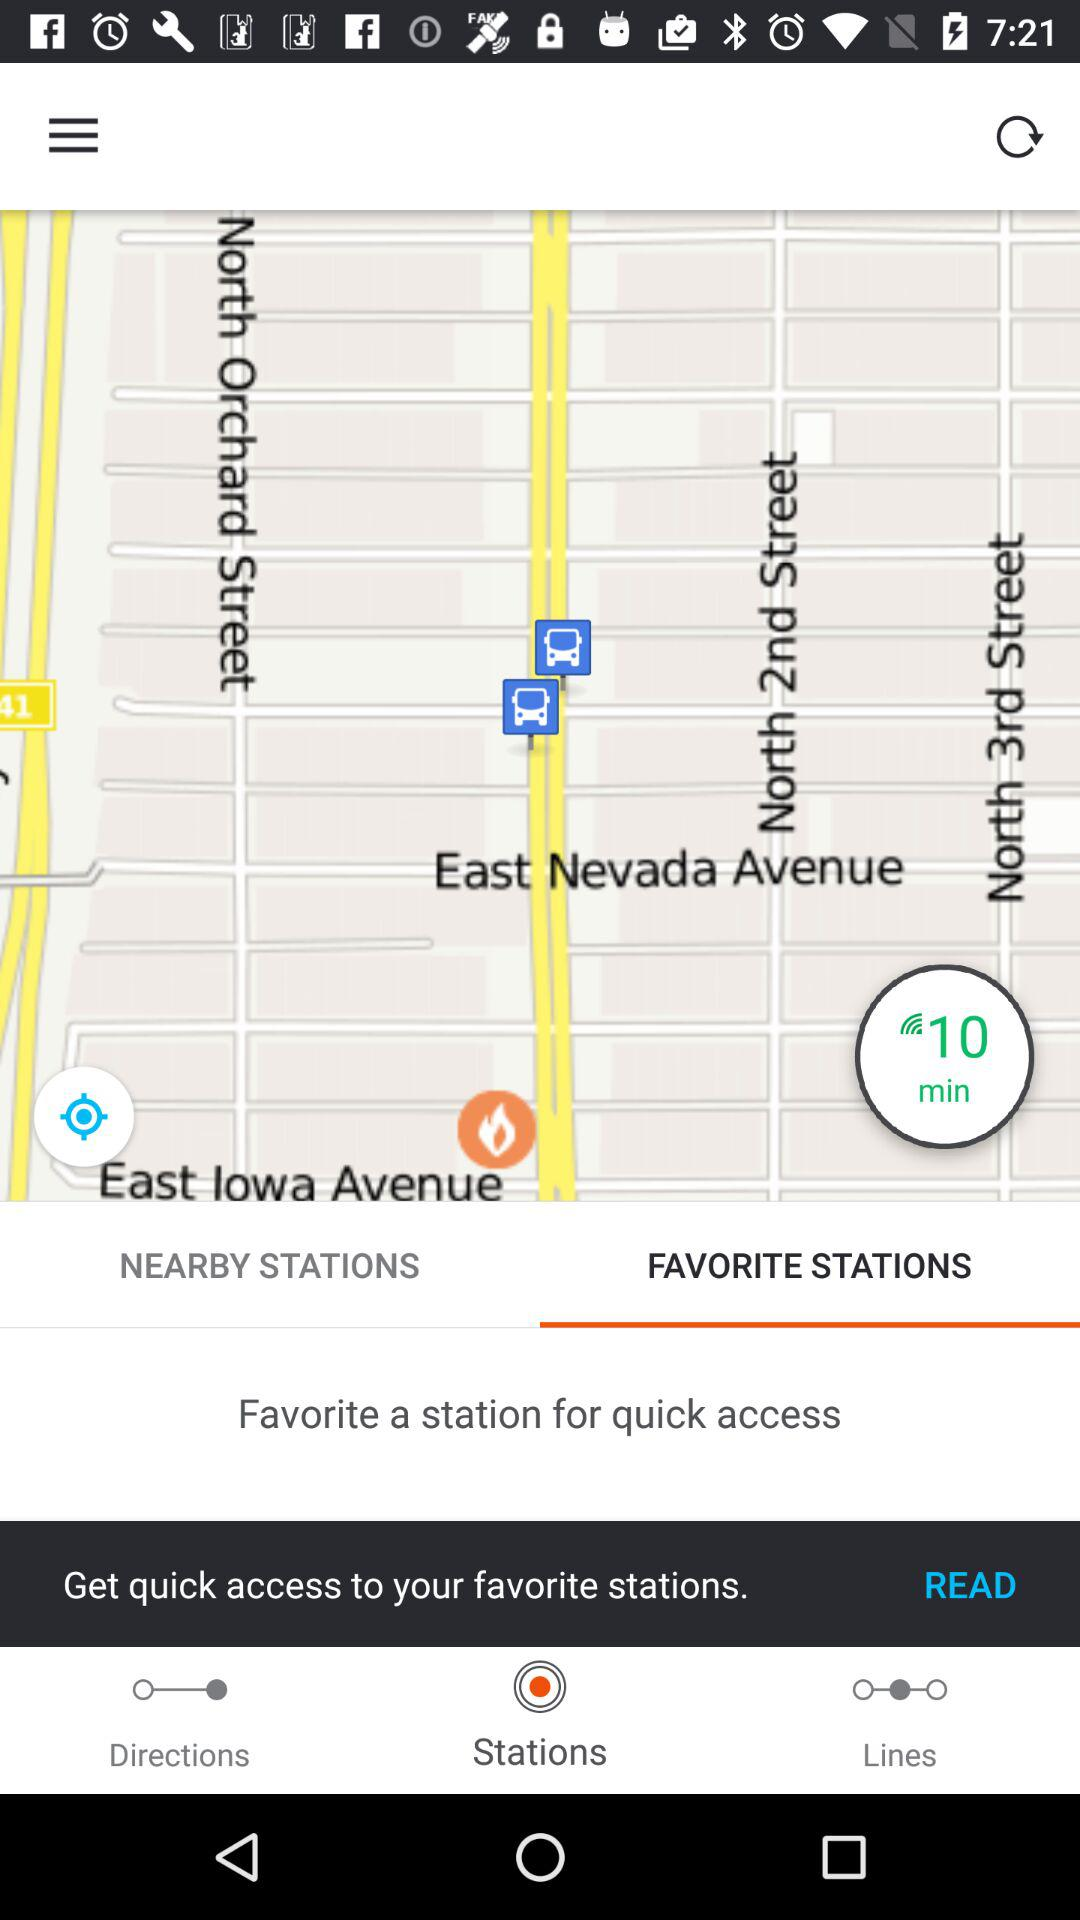How much time is shown? The shown time is 10 minutes. 